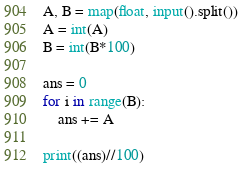Convert code to text. <code><loc_0><loc_0><loc_500><loc_500><_Python_>A, B = map(float, input().split())
A = int(A)
B = int(B*100)

ans = 0
for i in range(B):
    ans += A

print((ans)//100)</code> 